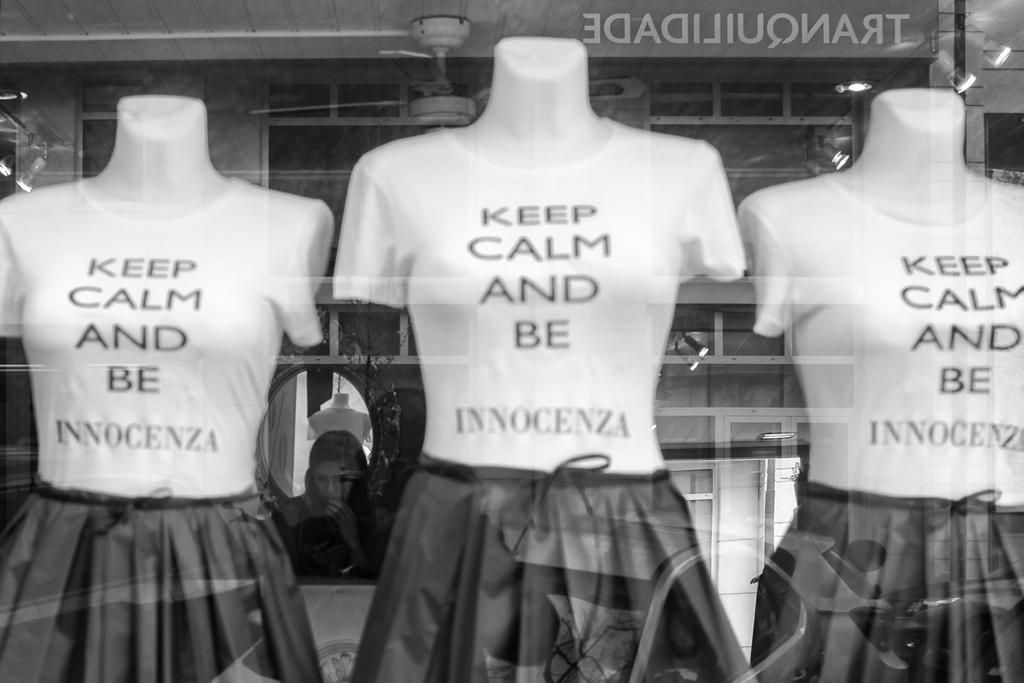Describe this image in one or two sentences. In the picture I can see three mannequins. I can see the T-shirts and frocks. In the background, I can see a woman. I can see the fan and lights on the roof. 